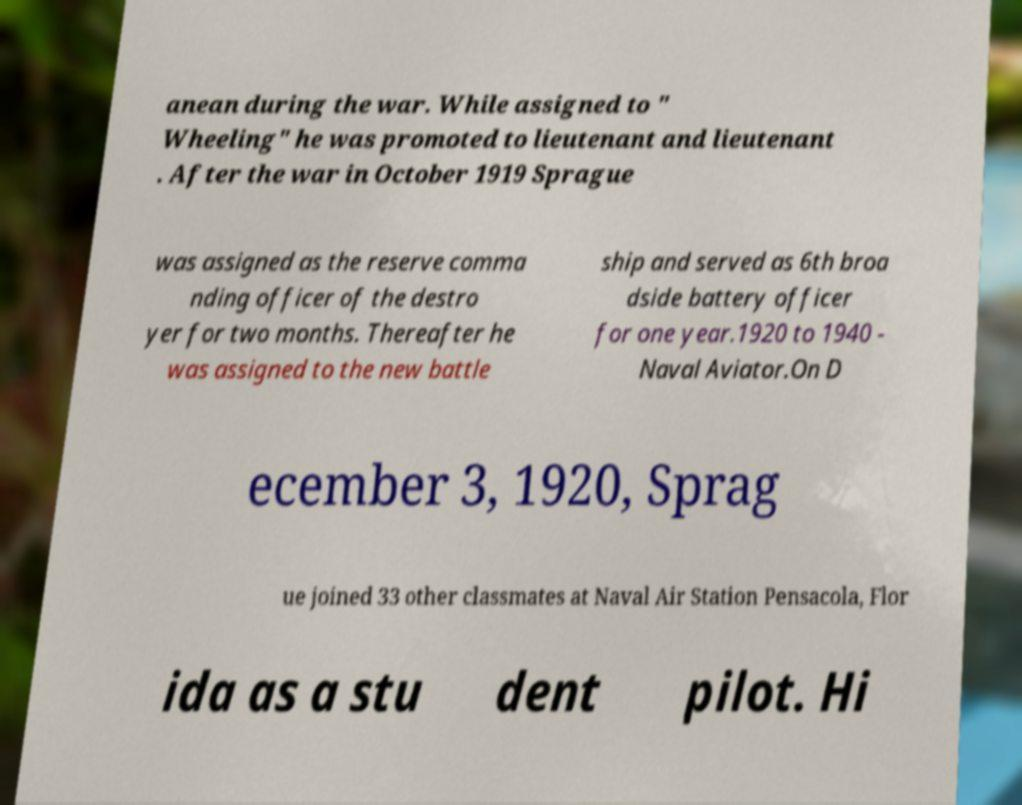What messages or text are displayed in this image? I need them in a readable, typed format. anean during the war. While assigned to " Wheeling" he was promoted to lieutenant and lieutenant . After the war in October 1919 Sprague was assigned as the reserve comma nding officer of the destro yer for two months. Thereafter he was assigned to the new battle ship and served as 6th broa dside battery officer for one year.1920 to 1940 - Naval Aviator.On D ecember 3, 1920, Sprag ue joined 33 other classmates at Naval Air Station Pensacola, Flor ida as a stu dent pilot. Hi 